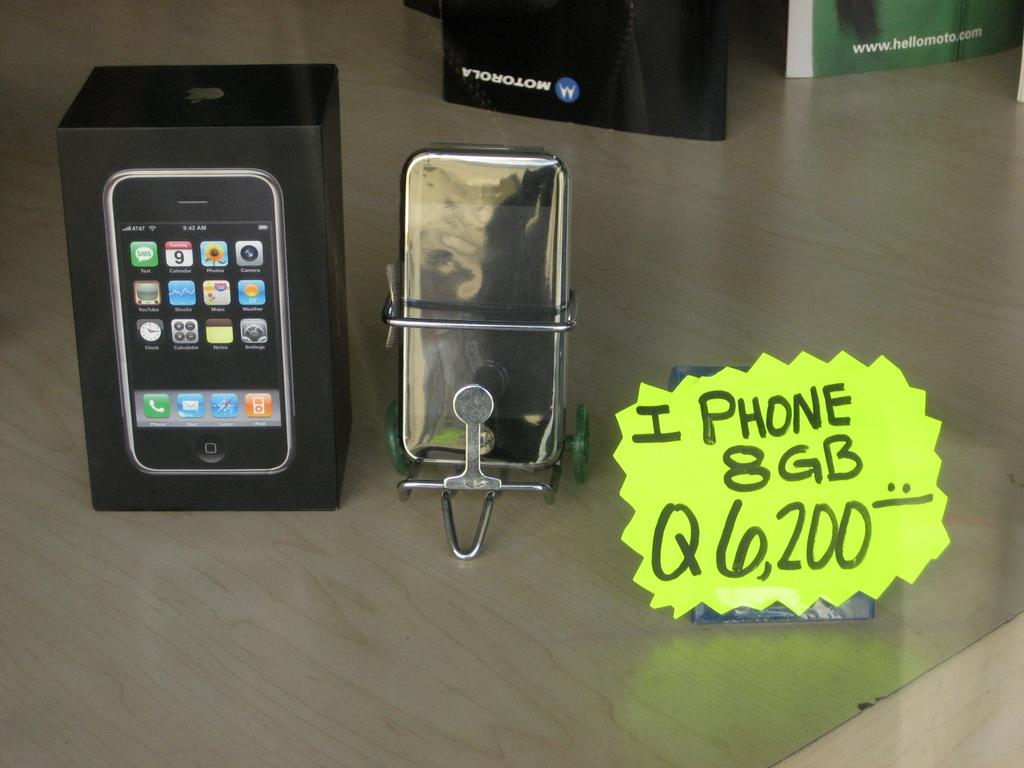<image>
Describe the image concisely. An iPhone is on display next to its packaging and a handwritten note that says iPhone 8GB Q6,200. 